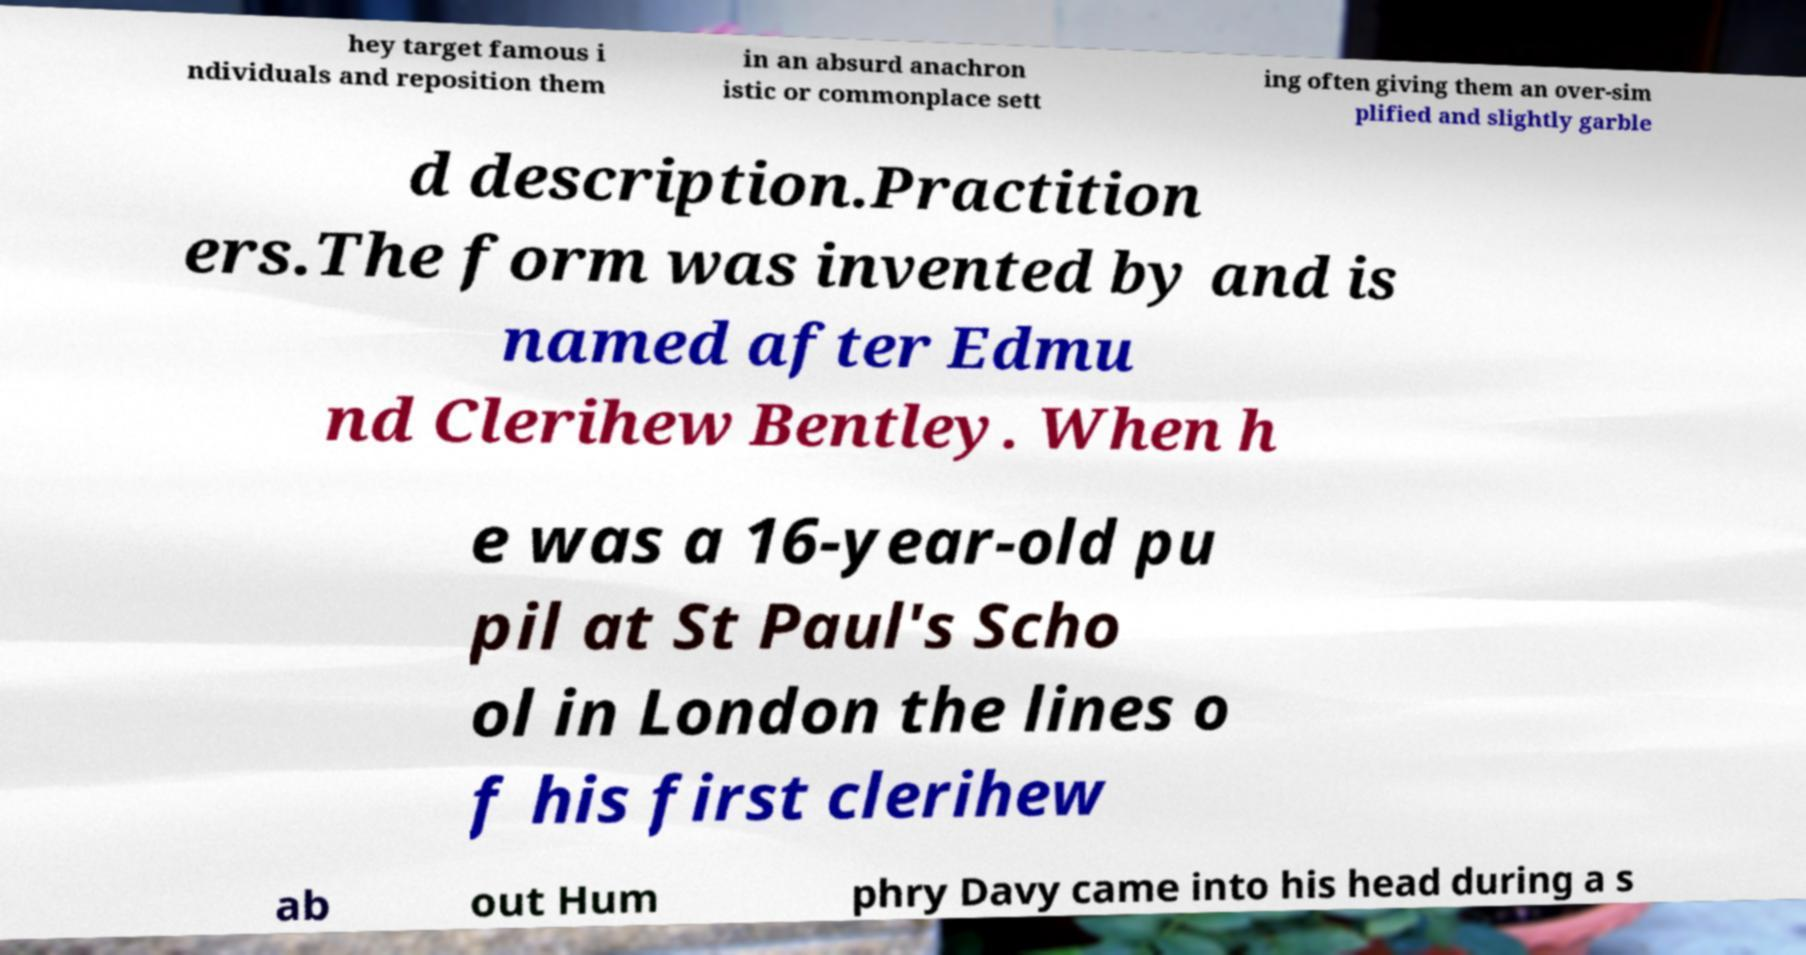Can you read and provide the text displayed in the image?This photo seems to have some interesting text. Can you extract and type it out for me? hey target famous i ndividuals and reposition them in an absurd anachron istic or commonplace sett ing often giving them an over-sim plified and slightly garble d description.Practition ers.The form was invented by and is named after Edmu nd Clerihew Bentley. When h e was a 16-year-old pu pil at St Paul's Scho ol in London the lines o f his first clerihew ab out Hum phry Davy came into his head during a s 